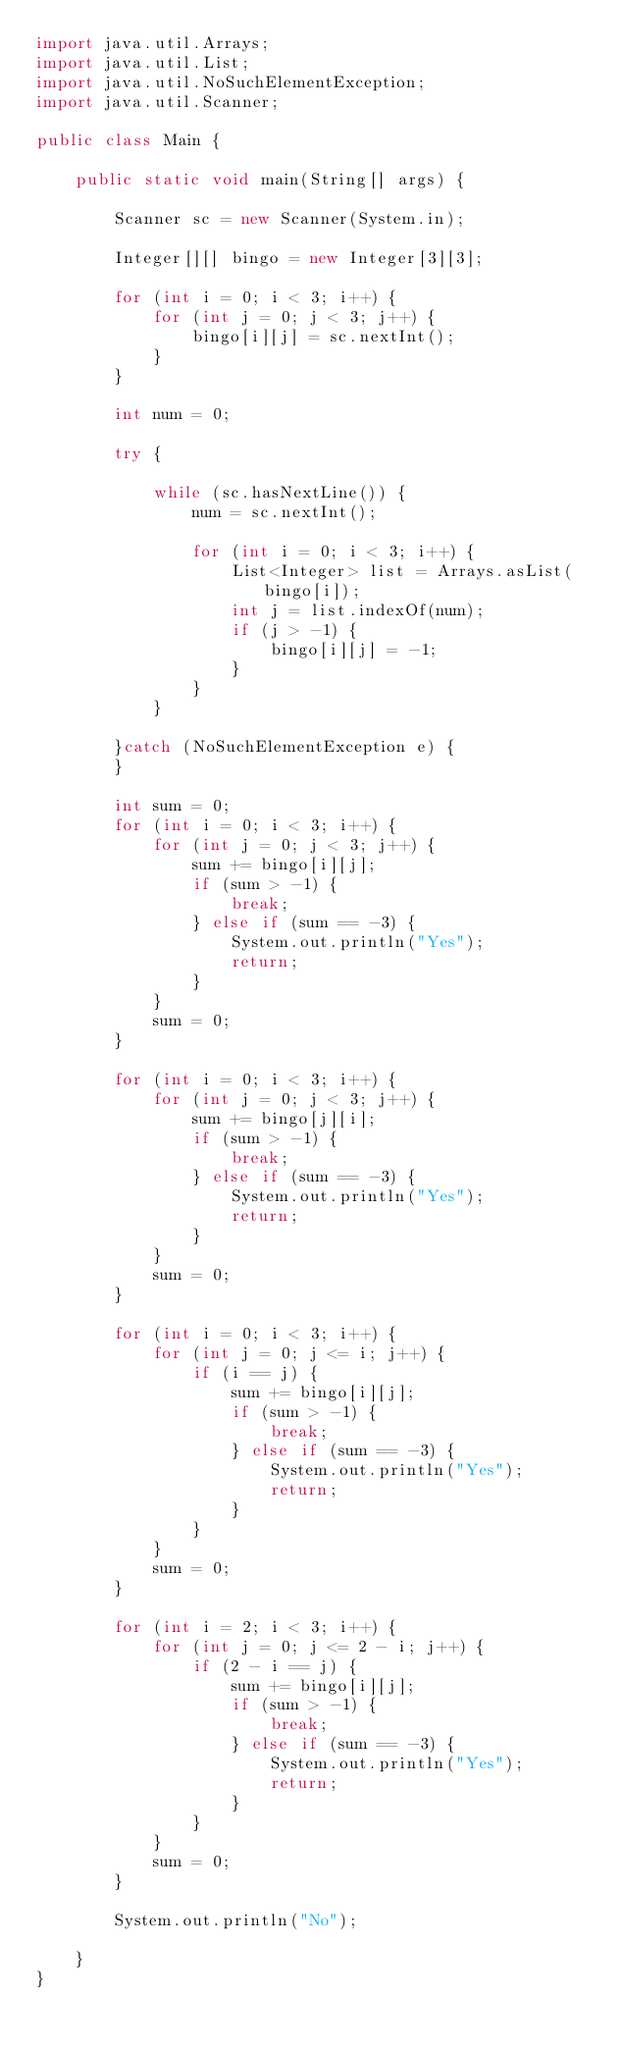<code> <loc_0><loc_0><loc_500><loc_500><_Java_>import java.util.Arrays;
import java.util.List;
import java.util.NoSuchElementException;
import java.util.Scanner;

public class Main {

	public static void main(String[] args) {

		Scanner sc = new Scanner(System.in);

		Integer[][] bingo = new Integer[3][3];

		for (int i = 0; i < 3; i++) {
			for (int j = 0; j < 3; j++) {
				bingo[i][j] = sc.nextInt();
			}
		}

		int num = 0;

		try {

			while (sc.hasNextLine()) {
				num = sc.nextInt();

				for (int i = 0; i < 3; i++) {
					List<Integer> list = Arrays.asList(bingo[i]);
					int j = list.indexOf(num);
					if (j > -1) {
						bingo[i][j] = -1;
					}
				}
			}

		}catch (NoSuchElementException e) {
		}

		int sum = 0;
		for (int i = 0; i < 3; i++) {
			for (int j = 0; j < 3; j++) {
				sum += bingo[i][j];
				if (sum > -1) {
					break;
				} else if (sum == -3) {
					System.out.println("Yes");
					return;
				}
			}
			sum = 0;
		}

		for (int i = 0; i < 3; i++) {
			for (int j = 0; j < 3; j++) {
				sum += bingo[j][i];
				if (sum > -1) {
					break;
				} else if (sum == -3) {
					System.out.println("Yes");
					return;
				}
			}
			sum = 0;
		}

		for (int i = 0; i < 3; i++) {
			for (int j = 0; j <= i; j++) {
				if (i == j) {
					sum += bingo[i][j];
					if (sum > -1) {
						break;
					} else if (sum == -3) {
						System.out.println("Yes");
						return;
					}
				}
			}
			sum = 0;
		}

		for (int i = 2; i < 3; i++) {
			for (int j = 0; j <= 2 - i; j++) {
				if (2 - i == j) {
					sum += bingo[i][j];
					if (sum > -1) {
						break;
					} else if (sum == -3) {
						System.out.println("Yes");
						return;
					}
				}
			}
			sum = 0;
		}

		System.out.println("No");

	}
}
</code> 